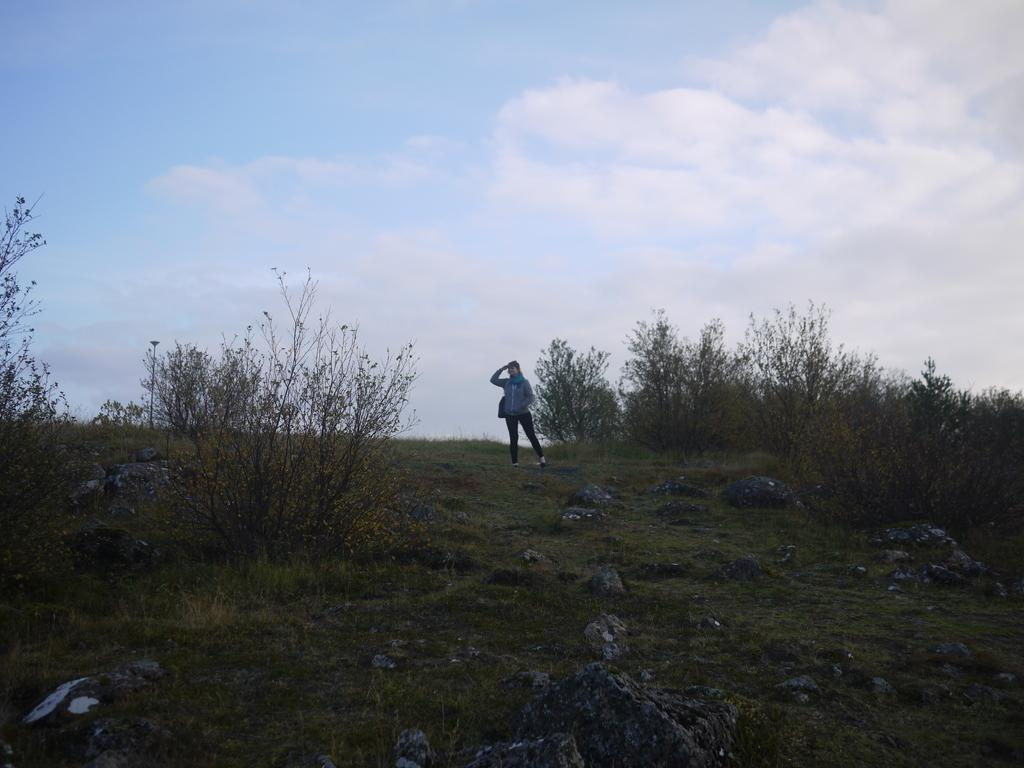What is the main subject of the image? There is a person standing in the image. What type of natural environment is depicted in the image? The image appears to depict a small hill with trees, rocks, and grass. What is visible in the background of the image? The sky is visible in the image. What type of game is being played on the hill in the image? There is no game being played in the image; it simply depicts a person standing on a hill with trees, rocks, grass, and the sky visible. 